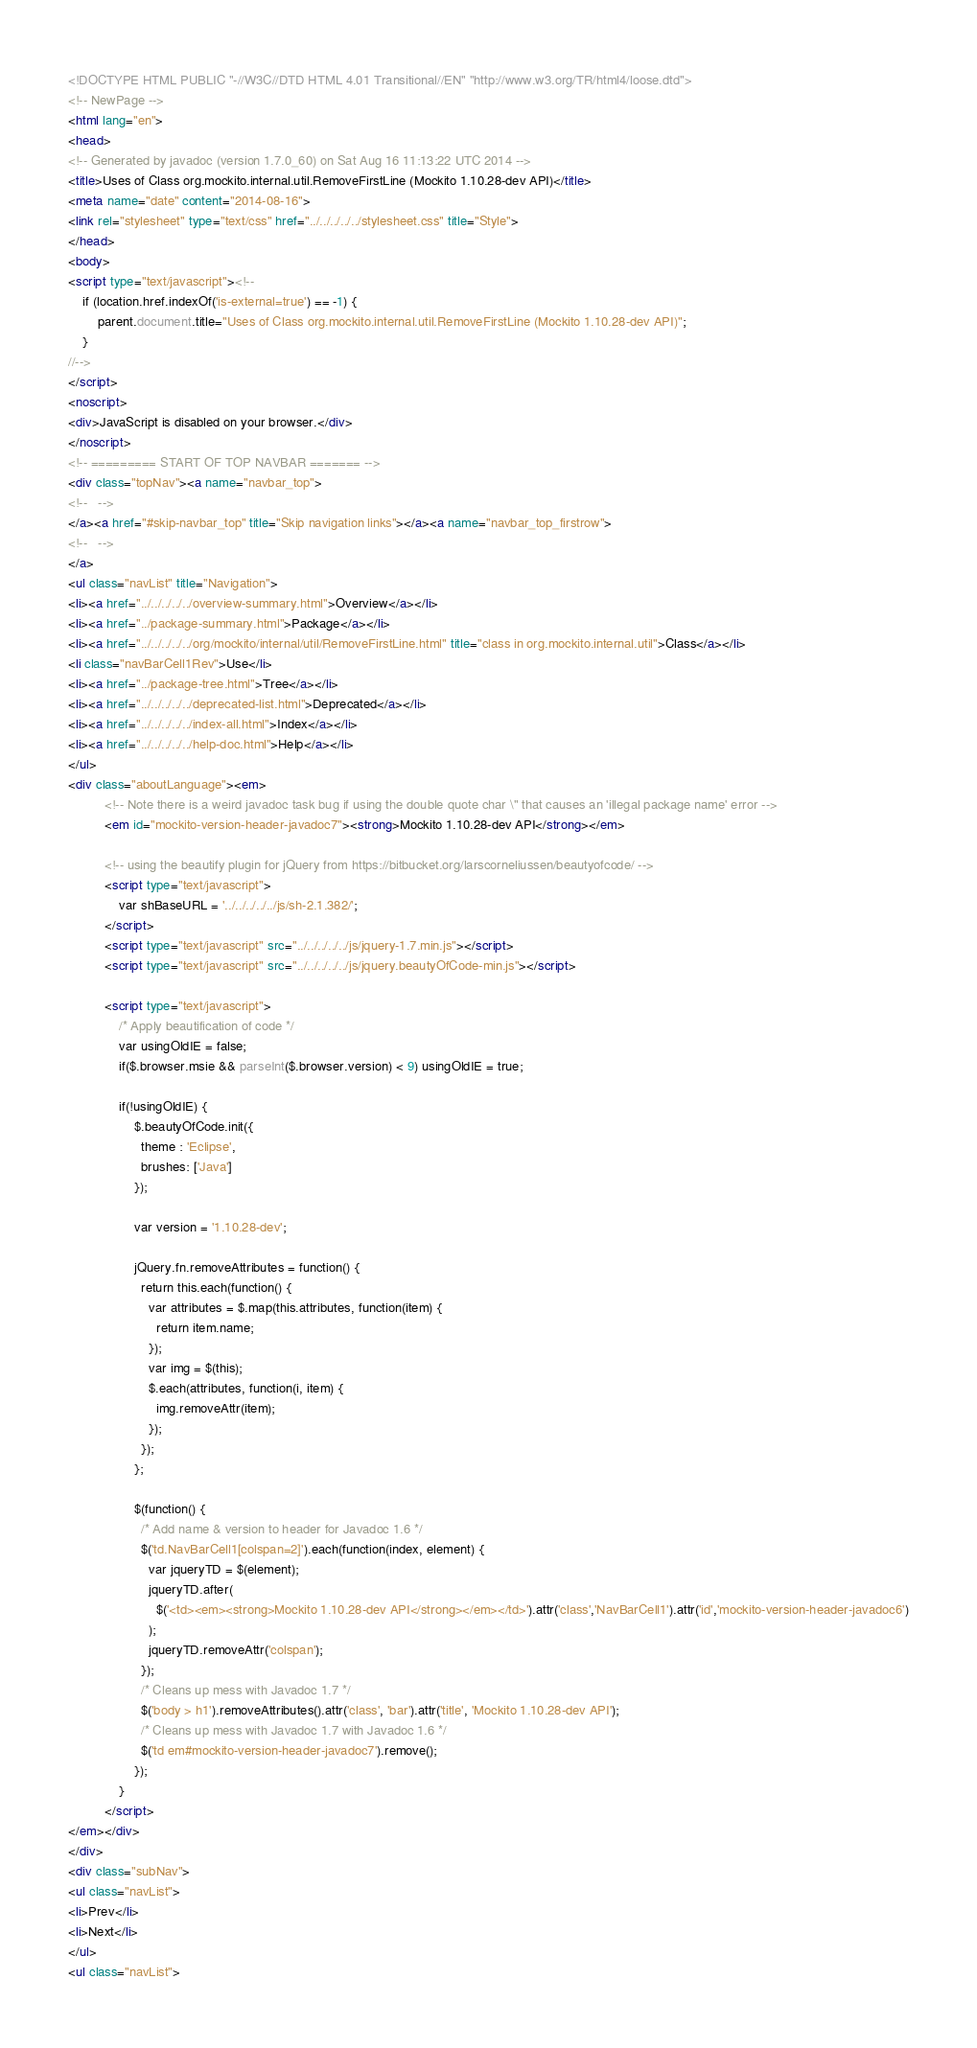<code> <loc_0><loc_0><loc_500><loc_500><_HTML_><!DOCTYPE HTML PUBLIC "-//W3C//DTD HTML 4.01 Transitional//EN" "http://www.w3.org/TR/html4/loose.dtd">
<!-- NewPage -->
<html lang="en">
<head>
<!-- Generated by javadoc (version 1.7.0_60) on Sat Aug 16 11:13:22 UTC 2014 -->
<title>Uses of Class org.mockito.internal.util.RemoveFirstLine (Mockito 1.10.28-dev API)</title>
<meta name="date" content="2014-08-16">
<link rel="stylesheet" type="text/css" href="../../../../../stylesheet.css" title="Style">
</head>
<body>
<script type="text/javascript"><!--
    if (location.href.indexOf('is-external=true') == -1) {
        parent.document.title="Uses of Class org.mockito.internal.util.RemoveFirstLine (Mockito 1.10.28-dev API)";
    }
//-->
</script>
<noscript>
<div>JavaScript is disabled on your browser.</div>
</noscript>
<!-- ========= START OF TOP NAVBAR ======= -->
<div class="topNav"><a name="navbar_top">
<!--   -->
</a><a href="#skip-navbar_top" title="Skip navigation links"></a><a name="navbar_top_firstrow">
<!--   -->
</a>
<ul class="navList" title="Navigation">
<li><a href="../../../../../overview-summary.html">Overview</a></li>
<li><a href="../package-summary.html">Package</a></li>
<li><a href="../../../../../org/mockito/internal/util/RemoveFirstLine.html" title="class in org.mockito.internal.util">Class</a></li>
<li class="navBarCell1Rev">Use</li>
<li><a href="../package-tree.html">Tree</a></li>
<li><a href="../../../../../deprecated-list.html">Deprecated</a></li>
<li><a href="../../../../../index-all.html">Index</a></li>
<li><a href="../../../../../help-doc.html">Help</a></li>
</ul>
<div class="aboutLanguage"><em>
          <!-- Note there is a weird javadoc task bug if using the double quote char \" that causes an 'illegal package name' error -->
          <em id="mockito-version-header-javadoc7"><strong>Mockito 1.10.28-dev API</strong></em>

          <!-- using the beautify plugin for jQuery from https://bitbucket.org/larscorneliussen/beautyofcode/ -->
          <script type="text/javascript">
              var shBaseURL = '../../../../../js/sh-2.1.382/';
          </script>
          <script type="text/javascript" src="../../../../../js/jquery-1.7.min.js"></script>
          <script type="text/javascript" src="../../../../../js/jquery.beautyOfCode-min.js"></script>

          <script type="text/javascript">
              /* Apply beautification of code */
              var usingOldIE = false;
              if($.browser.msie && parseInt($.browser.version) < 9) usingOldIE = true;

              if(!usingOldIE) {
                  $.beautyOfCode.init({
                    theme : 'Eclipse',
                    brushes: ['Java']
                  });

                  var version = '1.10.28-dev';

                  jQuery.fn.removeAttributes = function() {
                    return this.each(function() {
                      var attributes = $.map(this.attributes, function(item) {
                        return item.name;
                      });
                      var img = $(this);
                      $.each(attributes, function(i, item) {
                        img.removeAttr(item);
                      });
                    });
                  };

                  $(function() {
                    /* Add name & version to header for Javadoc 1.6 */
                    $('td.NavBarCell1[colspan=2]').each(function(index, element) {
                      var jqueryTD = $(element);
                      jqueryTD.after(
                        $('<td><em><strong>Mockito 1.10.28-dev API</strong></em></td>').attr('class','NavBarCell1').attr('id','mockito-version-header-javadoc6')
                      );
                      jqueryTD.removeAttr('colspan');
                    });
                    /* Cleans up mess with Javadoc 1.7 */
                    $('body > h1').removeAttributes().attr('class', 'bar').attr('title', 'Mockito 1.10.28-dev API');
                    /* Cleans up mess with Javadoc 1.7 with Javadoc 1.6 */
                    $('td em#mockito-version-header-javadoc7').remove();
                  });
              }
          </script>
</em></div>
</div>
<div class="subNav">
<ul class="navList">
<li>Prev</li>
<li>Next</li>
</ul>
<ul class="navList"></code> 